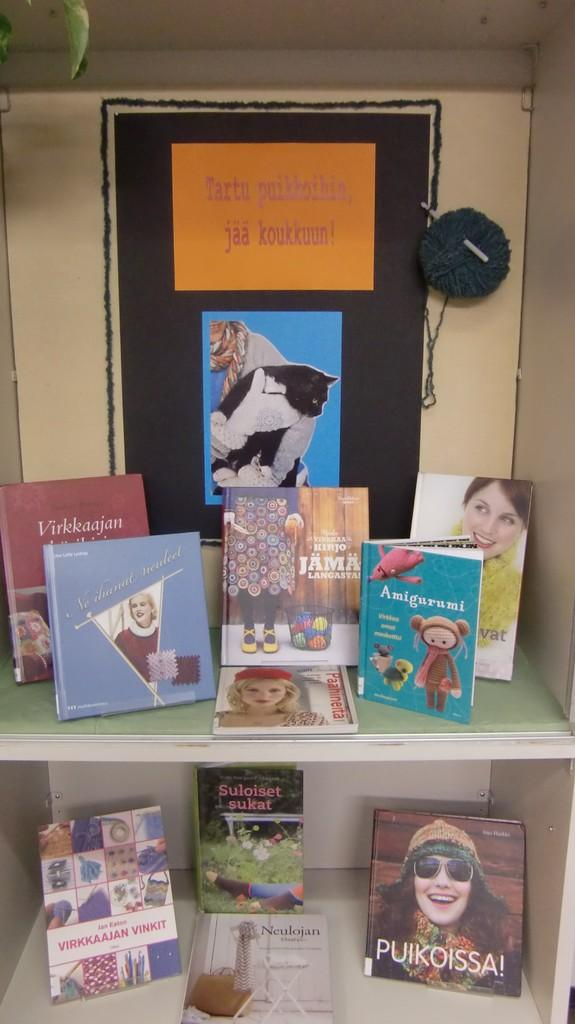Provide a one-sentence caption for the provided image. A shelf displaying several books including one called Amigurumi. 